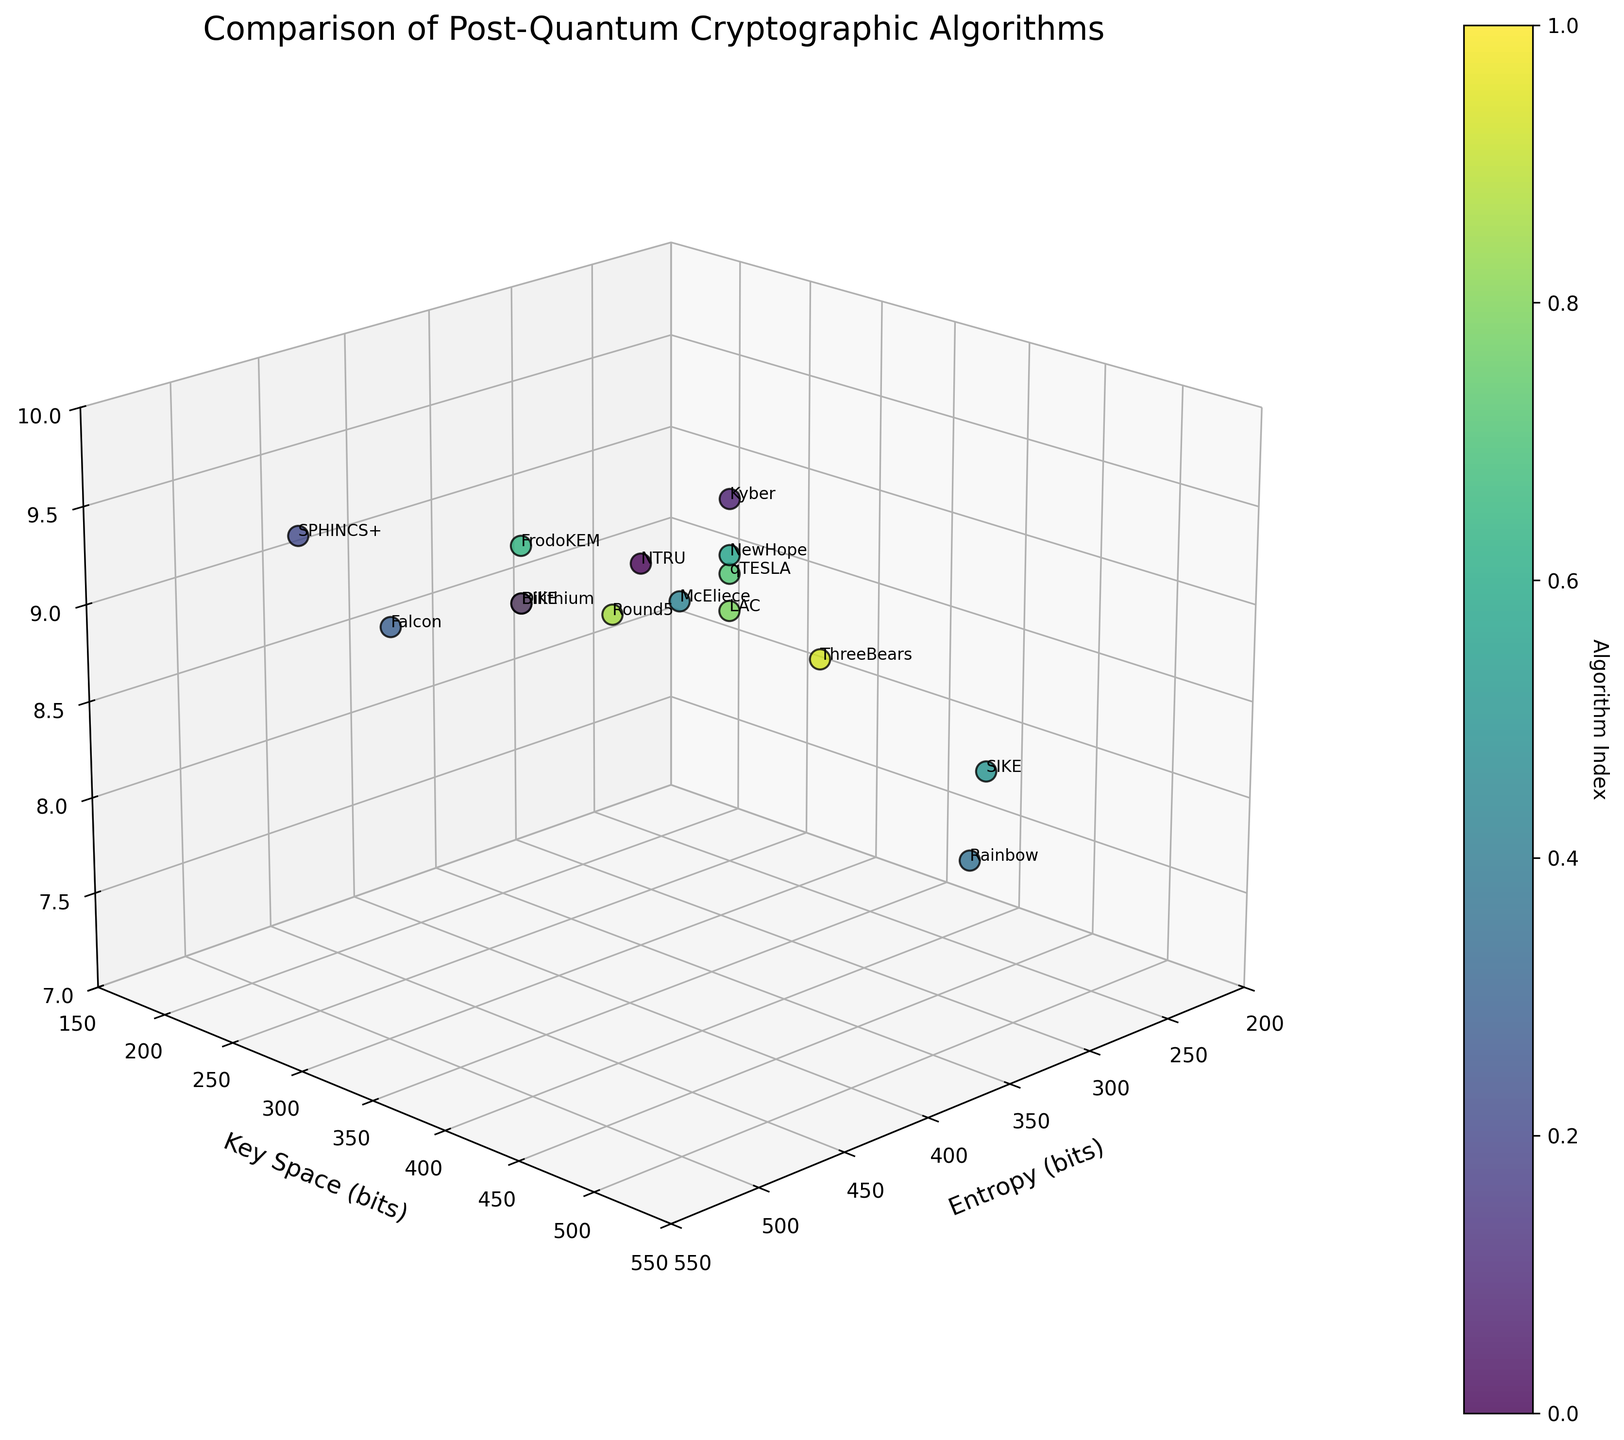What is the title of the figure? The title of the figure is usually written at the top within the plot area. Referring to the visual, the text at the top reads, "Comparison of Post-Quantum Cryptographic Algorithms".
Answer: Comparison of Post-Quantum Cryptographic Algorithms How many algorithms are compared in the figure? By counting the number of data points present in the scatter plot, one can determine the number of algorithms compared. Each point represents one algorithm, and there are 15 points in total.
Answer: 15 Which algorithm exhibits the highest entropy value? The algorithm with the highest entropy can be identified by looking at the x-axis, which represents entropy in bits. From the figure, McEliece, SPHINCS+, and Falcon have entropy values of 512 bits, but McEliece is the only one among them with the peak score in Quantum Resistance (close to 10)
Answer: McEliece Which algorithm has the largest key space? By examining the values on the y-axis that represent the key space in bits, SIKE has the largest key space because its y-coordinate value is 434, the highest among all data points.
Answer: SIKE What is the quantum resistance score for Kyber? To find Kyber's quantum resistance score, locate its data point and check its z-axis value. Kyber is labelled directly in the plot and has a quantum resistance score of 9.0.
Answer: 9.0 Which algorithm has the minimum quantum resistance score and what is it? To determine the algorithm with the minimum quantum resistance, find the point with the lowest z-axis value. Rainbow has the lowest quantum resistance score of 7.5.
Answer: Rainbow, 7.5 Compare the key space of Kyber and Falcon. Which one has more key space? By examining the y-axis values in the scatter plot, Kyber and Falcon's key spaces are noted. Kyber has a key space of 256 bits, whereas Falcon has a key space of 320 bits. Therefore, Falcon has more key space.
Answer: Falcon Which algorithm has both high entropy (512 bits) and the highest quantum resistance score? By looking at the highest values on the x-axis (entropy of 512 bits) and highest points on the z-axis (quantum resistance score), McEliece can be observed to have both high entropy and the highest quantum resistance score.
Answer: McEliece What is the average entropy value for the algorithms in the dataset? The entropy values provided are: 256, 256, 384, 512, 512, 256, 512, 256, 256, 384, 256, 256, 384, 256, 384. To find the average, sum them (4864) and divide by the number of algorithms (15): 4864 / 15 = 324.
Answer: 324 Does BIKE have a higher quantum resistance score than SIKE and by how much? Locate the quantum resistance scores on the z-axis for BIKE and SIKE. BIKE has a score of 8.8, while SIKE has 8.0. Calculation: 8.8 - 8.0 = 0.8
Answer: Yes, by 0.8 